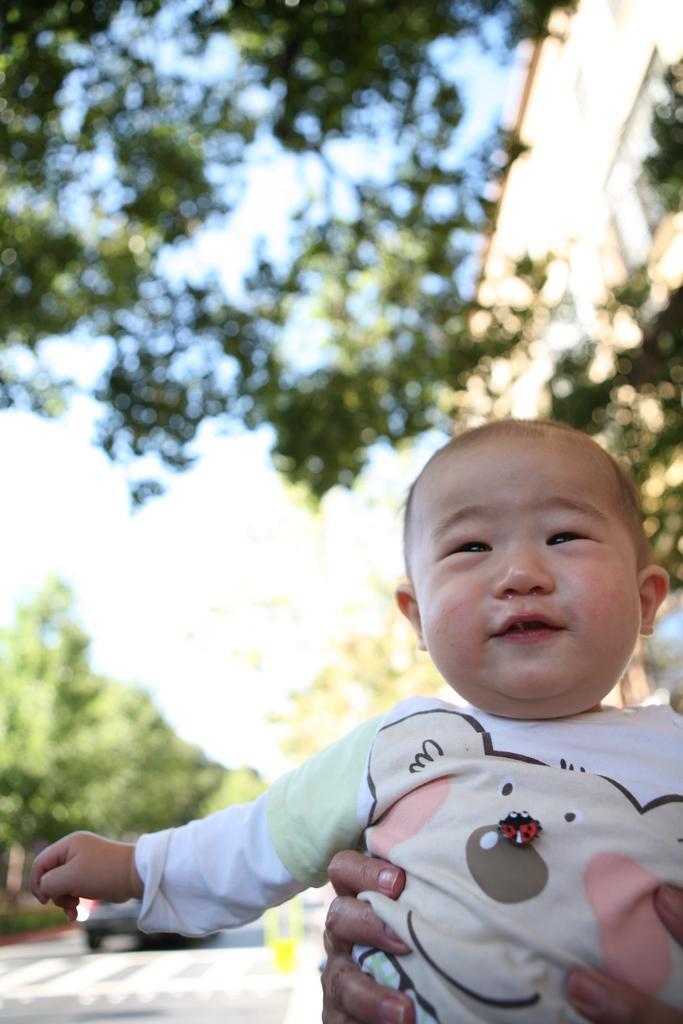Can you describe this image briefly? On the right side of the image we can see a building and a person is holding a kid. In the background of the image we can see the trees. At the bottom of the image we can see the road, board and the car. At the top of the image we can see the sky. 